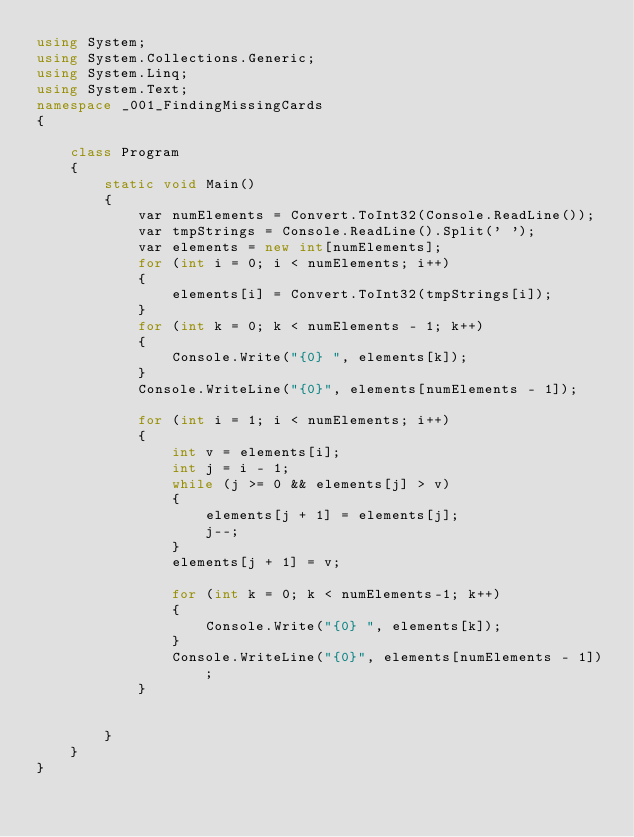Convert code to text. <code><loc_0><loc_0><loc_500><loc_500><_C#_>using System;
using System.Collections.Generic;
using System.Linq;
using System.Text;
namespace _001_FindingMissingCards
{

    class Program
    {
        static void Main()
        {
            var numElements = Convert.ToInt32(Console.ReadLine());
            var tmpStrings = Console.ReadLine().Split(' ');
            var elements = new int[numElements];
            for (int i = 0; i < numElements; i++)
            {
                elements[i] = Convert.ToInt32(tmpStrings[i]);
            }
            for (int k = 0; k < numElements - 1; k++)
            {
                Console.Write("{0} ", elements[k]);
            }
            Console.WriteLine("{0}", elements[numElements - 1]);

            for (int i = 1; i < numElements; i++)
            {
                int v = elements[i];
                int j = i - 1;
                while (j >= 0 && elements[j] > v)
                {
                    elements[j + 1] = elements[j];
                    j--;
                }
                elements[j + 1] = v;

                for (int k = 0; k < numElements-1; k++)
                {
                    Console.Write("{0} ", elements[k]);
                }
                Console.WriteLine("{0}", elements[numElements - 1]);
            }
            

        }
    }
}</code> 